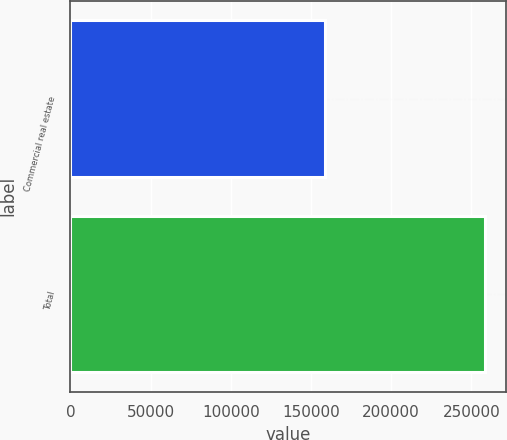<chart> <loc_0><loc_0><loc_500><loc_500><bar_chart><fcel>Commercial real estate<fcel>Total<nl><fcel>158597<fcel>258356<nl></chart> 